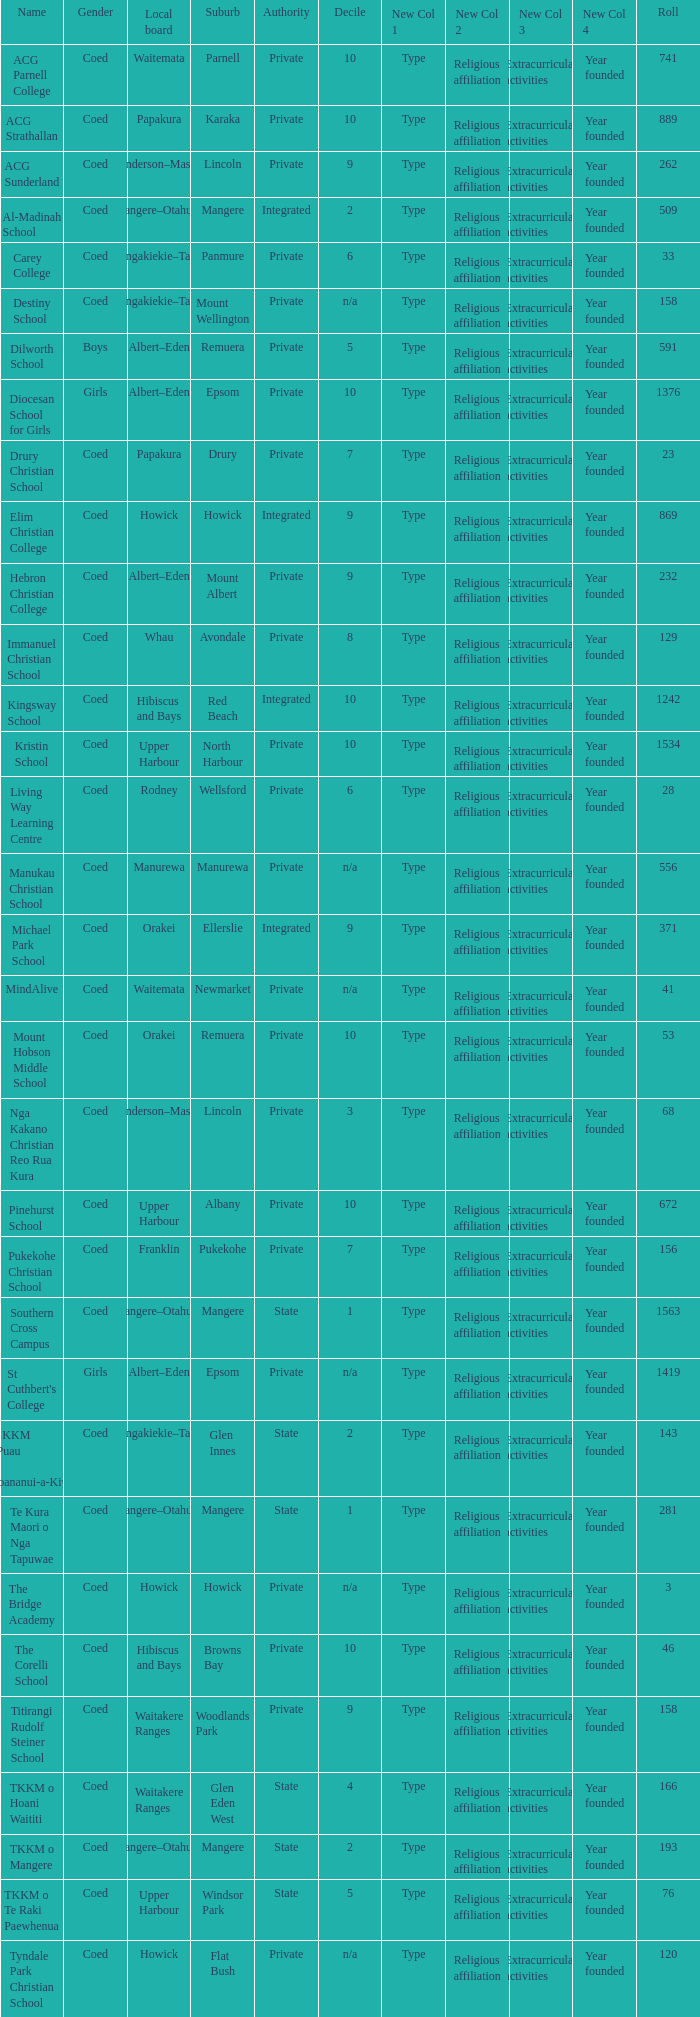What name shows as private authority and hibiscus and bays local board ? The Corelli School. 